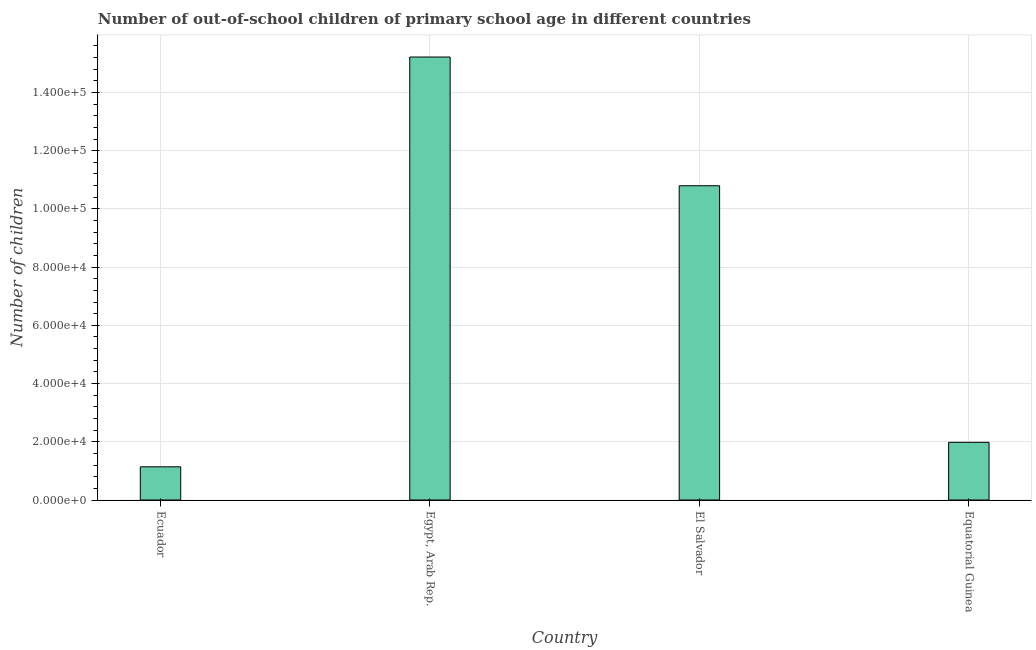What is the title of the graph?
Your answer should be very brief. Number of out-of-school children of primary school age in different countries. What is the label or title of the X-axis?
Your answer should be compact. Country. What is the label or title of the Y-axis?
Offer a very short reply. Number of children. What is the number of out-of-school children in Egypt, Arab Rep.?
Your answer should be compact. 1.52e+05. Across all countries, what is the maximum number of out-of-school children?
Offer a very short reply. 1.52e+05. Across all countries, what is the minimum number of out-of-school children?
Your answer should be compact. 1.14e+04. In which country was the number of out-of-school children maximum?
Offer a terse response. Egypt, Arab Rep. In which country was the number of out-of-school children minimum?
Your answer should be compact. Ecuador. What is the sum of the number of out-of-school children?
Give a very brief answer. 2.91e+05. What is the difference between the number of out-of-school children in Ecuador and Equatorial Guinea?
Offer a very short reply. -8406. What is the average number of out-of-school children per country?
Your answer should be compact. 7.28e+04. What is the median number of out-of-school children?
Provide a succinct answer. 6.39e+04. What is the ratio of the number of out-of-school children in Egypt, Arab Rep. to that in Equatorial Guinea?
Your response must be concise. 7.68. Is the number of out-of-school children in Egypt, Arab Rep. less than that in Equatorial Guinea?
Your answer should be compact. No. What is the difference between the highest and the second highest number of out-of-school children?
Your answer should be very brief. 4.42e+04. Is the sum of the number of out-of-school children in Egypt, Arab Rep. and El Salvador greater than the maximum number of out-of-school children across all countries?
Your response must be concise. Yes. What is the difference between the highest and the lowest number of out-of-school children?
Make the answer very short. 1.41e+05. In how many countries, is the number of out-of-school children greater than the average number of out-of-school children taken over all countries?
Make the answer very short. 2. How many bars are there?
Provide a short and direct response. 4. Are all the bars in the graph horizontal?
Make the answer very short. No. How many countries are there in the graph?
Offer a very short reply. 4. What is the Number of children of Ecuador?
Offer a very short reply. 1.14e+04. What is the Number of children in Egypt, Arab Rep.?
Offer a very short reply. 1.52e+05. What is the Number of children of El Salvador?
Provide a short and direct response. 1.08e+05. What is the Number of children in Equatorial Guinea?
Keep it short and to the point. 1.98e+04. What is the difference between the Number of children in Ecuador and Egypt, Arab Rep.?
Give a very brief answer. -1.41e+05. What is the difference between the Number of children in Ecuador and El Salvador?
Make the answer very short. -9.66e+04. What is the difference between the Number of children in Ecuador and Equatorial Guinea?
Offer a terse response. -8406. What is the difference between the Number of children in Egypt, Arab Rep. and El Salvador?
Ensure brevity in your answer.  4.42e+04. What is the difference between the Number of children in Egypt, Arab Rep. and Equatorial Guinea?
Offer a terse response. 1.32e+05. What is the difference between the Number of children in El Salvador and Equatorial Guinea?
Offer a very short reply. 8.81e+04. What is the ratio of the Number of children in Ecuador to that in Egypt, Arab Rep.?
Offer a terse response. 0.07. What is the ratio of the Number of children in Ecuador to that in El Salvador?
Make the answer very short. 0.11. What is the ratio of the Number of children in Ecuador to that in Equatorial Guinea?
Keep it short and to the point. 0.58. What is the ratio of the Number of children in Egypt, Arab Rep. to that in El Salvador?
Ensure brevity in your answer.  1.41. What is the ratio of the Number of children in Egypt, Arab Rep. to that in Equatorial Guinea?
Your answer should be very brief. 7.68. What is the ratio of the Number of children in El Salvador to that in Equatorial Guinea?
Your response must be concise. 5.45. 